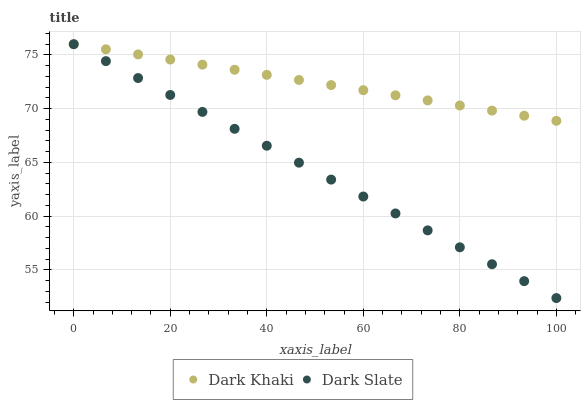Does Dark Slate have the minimum area under the curve?
Answer yes or no. Yes. Does Dark Khaki have the maximum area under the curve?
Answer yes or no. Yes. Does Dark Slate have the maximum area under the curve?
Answer yes or no. No. Is Dark Slate the smoothest?
Answer yes or no. Yes. Is Dark Khaki the roughest?
Answer yes or no. Yes. Is Dark Slate the roughest?
Answer yes or no. No. Does Dark Slate have the lowest value?
Answer yes or no. Yes. Does Dark Slate have the highest value?
Answer yes or no. Yes. Does Dark Khaki intersect Dark Slate?
Answer yes or no. Yes. Is Dark Khaki less than Dark Slate?
Answer yes or no. No. Is Dark Khaki greater than Dark Slate?
Answer yes or no. No. 